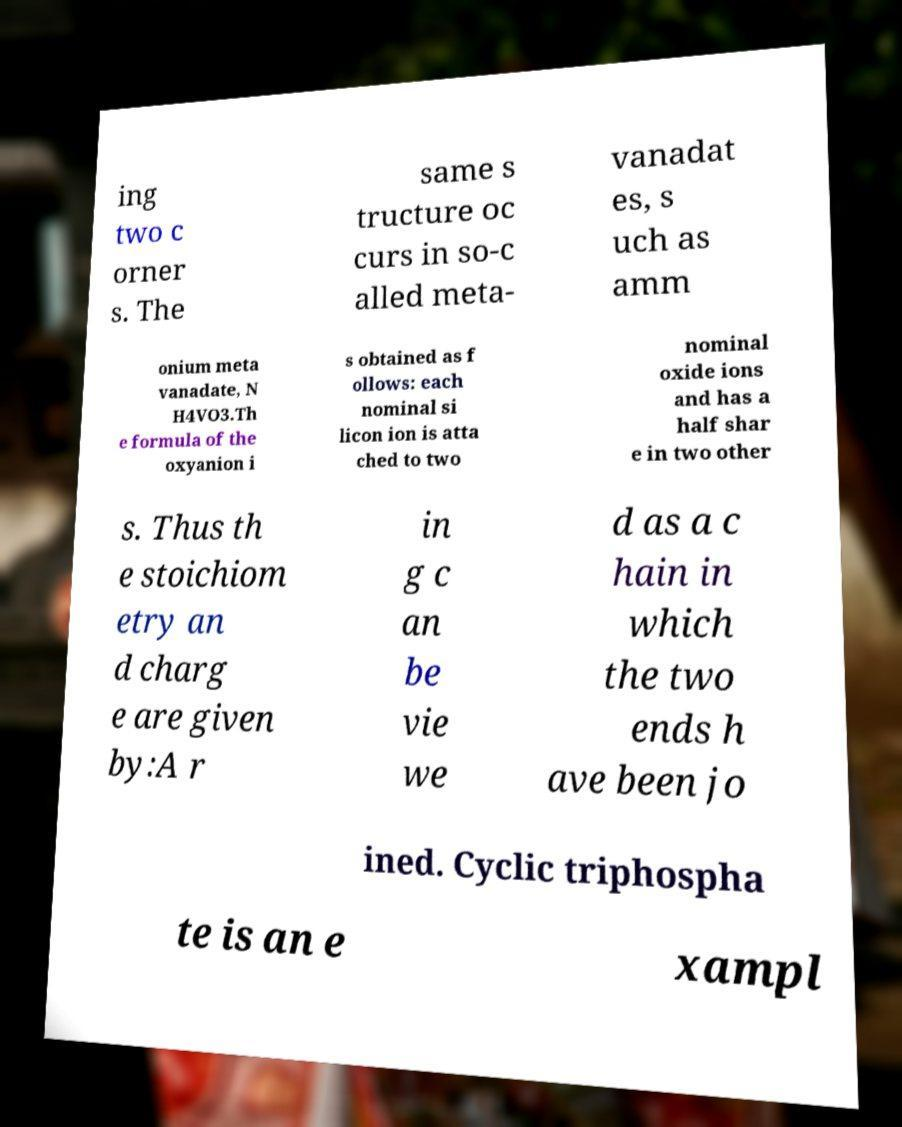Can you read and provide the text displayed in the image?This photo seems to have some interesting text. Can you extract and type it out for me? ing two c orner s. The same s tructure oc curs in so-c alled meta- vanadat es, s uch as amm onium meta vanadate, N H4VO3.Th e formula of the oxyanion i s obtained as f ollows: each nominal si licon ion is atta ched to two nominal oxide ions and has a half shar e in two other s. Thus th e stoichiom etry an d charg e are given by:A r in g c an be vie we d as a c hain in which the two ends h ave been jo ined. Cyclic triphospha te is an e xampl 